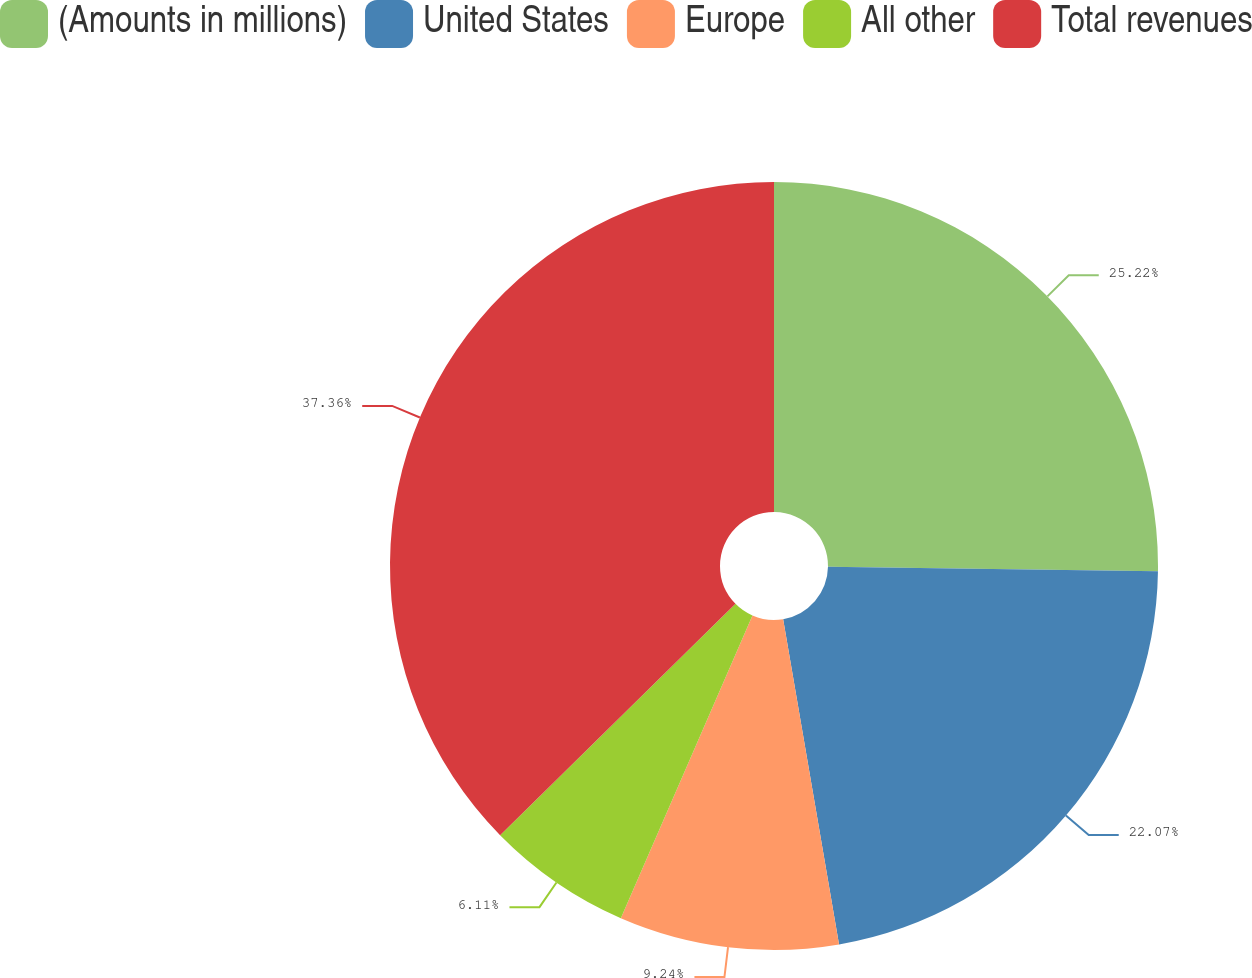Convert chart. <chart><loc_0><loc_0><loc_500><loc_500><pie_chart><fcel>(Amounts in millions)<fcel>United States<fcel>Europe<fcel>All other<fcel>Total revenues<nl><fcel>25.22%<fcel>22.07%<fcel>9.24%<fcel>6.11%<fcel>37.36%<nl></chart> 